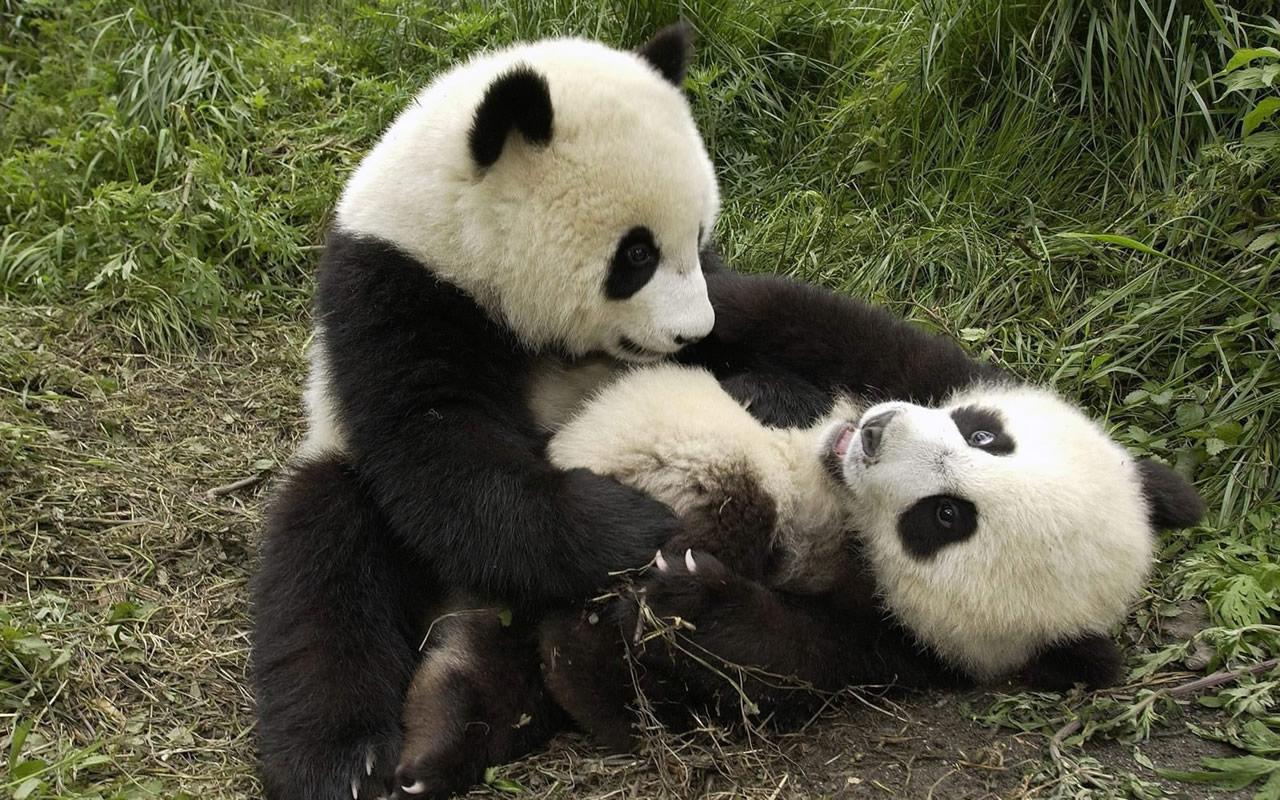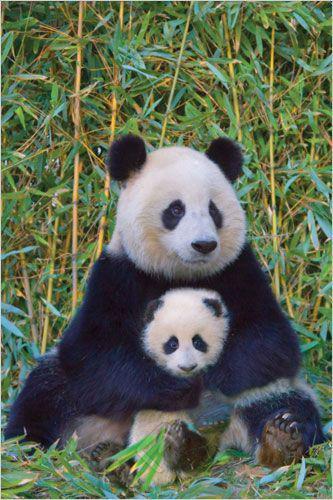The first image is the image on the left, the second image is the image on the right. Analyze the images presented: Is the assertion "An image shows exactly one panda, which is sitting and nibbling on a leafy stalk." valid? Answer yes or no. No. The first image is the image on the left, the second image is the image on the right. Assess this claim about the two images: "There are at least six pandas.". Correct or not? Answer yes or no. No. 